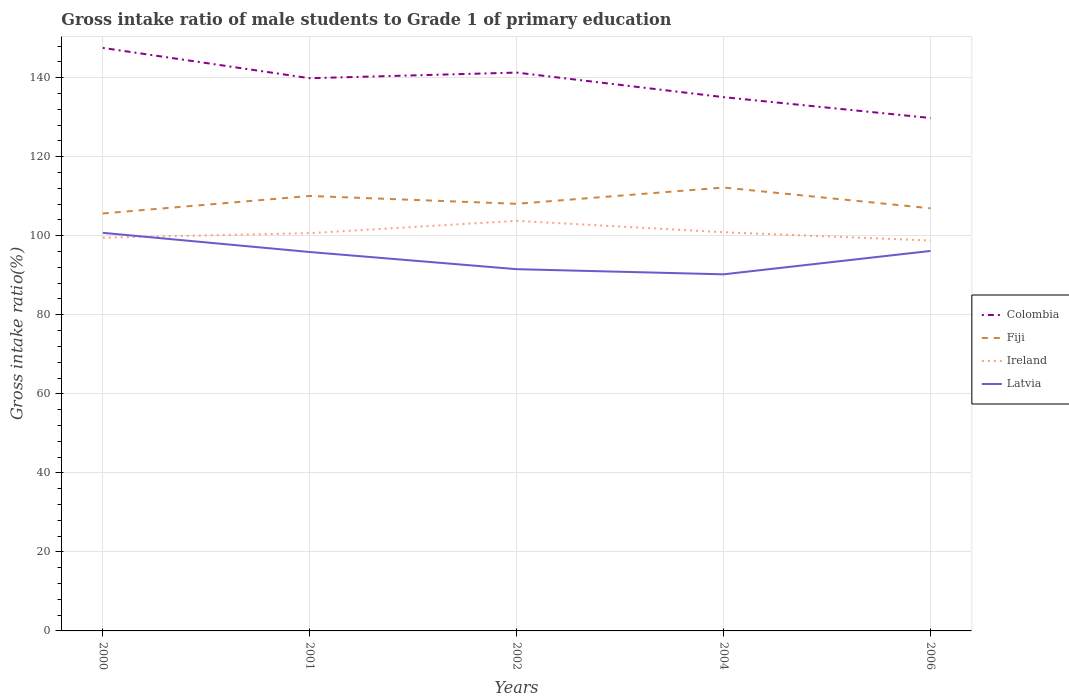Across all years, what is the maximum gross intake ratio in Latvia?
Provide a succinct answer. 90.24. What is the total gross intake ratio in Ireland in the graph?
Give a very brief answer. -0.23. What is the difference between the highest and the second highest gross intake ratio in Colombia?
Your answer should be very brief. 17.74. Is the gross intake ratio in Latvia strictly greater than the gross intake ratio in Fiji over the years?
Provide a short and direct response. Yes. What is the difference between two consecutive major ticks on the Y-axis?
Your response must be concise. 20. Are the values on the major ticks of Y-axis written in scientific E-notation?
Provide a short and direct response. No. Does the graph contain grids?
Provide a succinct answer. Yes. Where does the legend appear in the graph?
Give a very brief answer. Center right. What is the title of the graph?
Give a very brief answer. Gross intake ratio of male students to Grade 1 of primary education. Does "Lebanon" appear as one of the legend labels in the graph?
Provide a succinct answer. No. What is the label or title of the X-axis?
Give a very brief answer. Years. What is the label or title of the Y-axis?
Provide a short and direct response. Gross intake ratio(%). What is the Gross intake ratio(%) in Colombia in 2000?
Your answer should be compact. 147.53. What is the Gross intake ratio(%) in Fiji in 2000?
Offer a very short reply. 105.64. What is the Gross intake ratio(%) in Ireland in 2000?
Ensure brevity in your answer.  99.51. What is the Gross intake ratio(%) of Latvia in 2000?
Give a very brief answer. 100.74. What is the Gross intake ratio(%) of Colombia in 2001?
Offer a very short reply. 139.86. What is the Gross intake ratio(%) of Fiji in 2001?
Give a very brief answer. 110.07. What is the Gross intake ratio(%) in Ireland in 2001?
Your response must be concise. 100.65. What is the Gross intake ratio(%) of Latvia in 2001?
Your response must be concise. 95.88. What is the Gross intake ratio(%) of Colombia in 2002?
Provide a short and direct response. 141.29. What is the Gross intake ratio(%) of Fiji in 2002?
Your answer should be compact. 108.08. What is the Gross intake ratio(%) of Ireland in 2002?
Make the answer very short. 103.77. What is the Gross intake ratio(%) of Latvia in 2002?
Provide a succinct answer. 91.54. What is the Gross intake ratio(%) of Colombia in 2004?
Give a very brief answer. 135.07. What is the Gross intake ratio(%) of Fiji in 2004?
Offer a terse response. 112.2. What is the Gross intake ratio(%) in Ireland in 2004?
Provide a succinct answer. 100.88. What is the Gross intake ratio(%) in Latvia in 2004?
Your response must be concise. 90.24. What is the Gross intake ratio(%) in Colombia in 2006?
Keep it short and to the point. 129.8. What is the Gross intake ratio(%) in Fiji in 2006?
Offer a very short reply. 106.95. What is the Gross intake ratio(%) of Ireland in 2006?
Provide a short and direct response. 98.79. What is the Gross intake ratio(%) in Latvia in 2006?
Your answer should be very brief. 96.15. Across all years, what is the maximum Gross intake ratio(%) of Colombia?
Ensure brevity in your answer.  147.53. Across all years, what is the maximum Gross intake ratio(%) of Fiji?
Provide a succinct answer. 112.2. Across all years, what is the maximum Gross intake ratio(%) of Ireland?
Ensure brevity in your answer.  103.77. Across all years, what is the maximum Gross intake ratio(%) of Latvia?
Ensure brevity in your answer.  100.74. Across all years, what is the minimum Gross intake ratio(%) of Colombia?
Make the answer very short. 129.8. Across all years, what is the minimum Gross intake ratio(%) in Fiji?
Provide a short and direct response. 105.64. Across all years, what is the minimum Gross intake ratio(%) in Ireland?
Offer a very short reply. 98.79. Across all years, what is the minimum Gross intake ratio(%) of Latvia?
Ensure brevity in your answer.  90.24. What is the total Gross intake ratio(%) of Colombia in the graph?
Ensure brevity in your answer.  693.55. What is the total Gross intake ratio(%) in Fiji in the graph?
Your response must be concise. 542.93. What is the total Gross intake ratio(%) in Ireland in the graph?
Offer a very short reply. 503.62. What is the total Gross intake ratio(%) of Latvia in the graph?
Offer a terse response. 474.54. What is the difference between the Gross intake ratio(%) in Colombia in 2000 and that in 2001?
Offer a very short reply. 7.67. What is the difference between the Gross intake ratio(%) in Fiji in 2000 and that in 2001?
Offer a very short reply. -4.43. What is the difference between the Gross intake ratio(%) of Ireland in 2000 and that in 2001?
Give a very brief answer. -1.14. What is the difference between the Gross intake ratio(%) in Latvia in 2000 and that in 2001?
Your response must be concise. 4.85. What is the difference between the Gross intake ratio(%) of Colombia in 2000 and that in 2002?
Offer a terse response. 6.25. What is the difference between the Gross intake ratio(%) of Fiji in 2000 and that in 2002?
Provide a succinct answer. -2.45. What is the difference between the Gross intake ratio(%) in Ireland in 2000 and that in 2002?
Your answer should be compact. -4.26. What is the difference between the Gross intake ratio(%) in Latvia in 2000 and that in 2002?
Provide a succinct answer. 9.2. What is the difference between the Gross intake ratio(%) in Colombia in 2000 and that in 2004?
Keep it short and to the point. 12.46. What is the difference between the Gross intake ratio(%) of Fiji in 2000 and that in 2004?
Give a very brief answer. -6.57. What is the difference between the Gross intake ratio(%) in Ireland in 2000 and that in 2004?
Ensure brevity in your answer.  -1.37. What is the difference between the Gross intake ratio(%) of Latvia in 2000 and that in 2004?
Offer a terse response. 10.5. What is the difference between the Gross intake ratio(%) in Colombia in 2000 and that in 2006?
Ensure brevity in your answer.  17.74. What is the difference between the Gross intake ratio(%) in Fiji in 2000 and that in 2006?
Keep it short and to the point. -1.31. What is the difference between the Gross intake ratio(%) of Ireland in 2000 and that in 2006?
Offer a very short reply. 0.72. What is the difference between the Gross intake ratio(%) of Latvia in 2000 and that in 2006?
Provide a short and direct response. 4.59. What is the difference between the Gross intake ratio(%) of Colombia in 2001 and that in 2002?
Your answer should be compact. -1.42. What is the difference between the Gross intake ratio(%) in Fiji in 2001 and that in 2002?
Keep it short and to the point. 1.99. What is the difference between the Gross intake ratio(%) in Ireland in 2001 and that in 2002?
Make the answer very short. -3.12. What is the difference between the Gross intake ratio(%) in Latvia in 2001 and that in 2002?
Provide a short and direct response. 4.34. What is the difference between the Gross intake ratio(%) in Colombia in 2001 and that in 2004?
Ensure brevity in your answer.  4.79. What is the difference between the Gross intake ratio(%) in Fiji in 2001 and that in 2004?
Provide a succinct answer. -2.13. What is the difference between the Gross intake ratio(%) in Ireland in 2001 and that in 2004?
Ensure brevity in your answer.  -0.23. What is the difference between the Gross intake ratio(%) of Latvia in 2001 and that in 2004?
Offer a very short reply. 5.65. What is the difference between the Gross intake ratio(%) of Colombia in 2001 and that in 2006?
Offer a very short reply. 10.07. What is the difference between the Gross intake ratio(%) in Fiji in 2001 and that in 2006?
Ensure brevity in your answer.  3.12. What is the difference between the Gross intake ratio(%) of Ireland in 2001 and that in 2006?
Your response must be concise. 1.86. What is the difference between the Gross intake ratio(%) of Latvia in 2001 and that in 2006?
Ensure brevity in your answer.  -0.27. What is the difference between the Gross intake ratio(%) of Colombia in 2002 and that in 2004?
Your answer should be very brief. 6.22. What is the difference between the Gross intake ratio(%) of Fiji in 2002 and that in 2004?
Give a very brief answer. -4.12. What is the difference between the Gross intake ratio(%) in Ireland in 2002 and that in 2004?
Provide a succinct answer. 2.89. What is the difference between the Gross intake ratio(%) in Latvia in 2002 and that in 2004?
Provide a short and direct response. 1.3. What is the difference between the Gross intake ratio(%) of Colombia in 2002 and that in 2006?
Keep it short and to the point. 11.49. What is the difference between the Gross intake ratio(%) of Fiji in 2002 and that in 2006?
Your answer should be very brief. 1.13. What is the difference between the Gross intake ratio(%) in Ireland in 2002 and that in 2006?
Offer a very short reply. 4.98. What is the difference between the Gross intake ratio(%) of Latvia in 2002 and that in 2006?
Provide a short and direct response. -4.61. What is the difference between the Gross intake ratio(%) in Colombia in 2004 and that in 2006?
Offer a terse response. 5.27. What is the difference between the Gross intake ratio(%) in Fiji in 2004 and that in 2006?
Provide a succinct answer. 5.26. What is the difference between the Gross intake ratio(%) in Ireland in 2004 and that in 2006?
Offer a terse response. 2.09. What is the difference between the Gross intake ratio(%) of Latvia in 2004 and that in 2006?
Make the answer very short. -5.91. What is the difference between the Gross intake ratio(%) of Colombia in 2000 and the Gross intake ratio(%) of Fiji in 2001?
Provide a short and direct response. 37.46. What is the difference between the Gross intake ratio(%) of Colombia in 2000 and the Gross intake ratio(%) of Ireland in 2001?
Make the answer very short. 46.88. What is the difference between the Gross intake ratio(%) of Colombia in 2000 and the Gross intake ratio(%) of Latvia in 2001?
Your answer should be very brief. 51.65. What is the difference between the Gross intake ratio(%) in Fiji in 2000 and the Gross intake ratio(%) in Ireland in 2001?
Offer a terse response. 4.98. What is the difference between the Gross intake ratio(%) in Fiji in 2000 and the Gross intake ratio(%) in Latvia in 2001?
Your response must be concise. 9.75. What is the difference between the Gross intake ratio(%) of Ireland in 2000 and the Gross intake ratio(%) of Latvia in 2001?
Provide a short and direct response. 3.63. What is the difference between the Gross intake ratio(%) in Colombia in 2000 and the Gross intake ratio(%) in Fiji in 2002?
Your answer should be compact. 39.45. What is the difference between the Gross intake ratio(%) in Colombia in 2000 and the Gross intake ratio(%) in Ireland in 2002?
Make the answer very short. 43.76. What is the difference between the Gross intake ratio(%) of Colombia in 2000 and the Gross intake ratio(%) of Latvia in 2002?
Offer a very short reply. 55.99. What is the difference between the Gross intake ratio(%) in Fiji in 2000 and the Gross intake ratio(%) in Ireland in 2002?
Make the answer very short. 1.86. What is the difference between the Gross intake ratio(%) of Fiji in 2000 and the Gross intake ratio(%) of Latvia in 2002?
Keep it short and to the point. 14.1. What is the difference between the Gross intake ratio(%) of Ireland in 2000 and the Gross intake ratio(%) of Latvia in 2002?
Keep it short and to the point. 7.97. What is the difference between the Gross intake ratio(%) in Colombia in 2000 and the Gross intake ratio(%) in Fiji in 2004?
Keep it short and to the point. 35.33. What is the difference between the Gross intake ratio(%) of Colombia in 2000 and the Gross intake ratio(%) of Ireland in 2004?
Offer a terse response. 46.65. What is the difference between the Gross intake ratio(%) in Colombia in 2000 and the Gross intake ratio(%) in Latvia in 2004?
Provide a succinct answer. 57.3. What is the difference between the Gross intake ratio(%) of Fiji in 2000 and the Gross intake ratio(%) of Ireland in 2004?
Provide a short and direct response. 4.75. What is the difference between the Gross intake ratio(%) in Fiji in 2000 and the Gross intake ratio(%) in Latvia in 2004?
Your answer should be compact. 15.4. What is the difference between the Gross intake ratio(%) in Ireland in 2000 and the Gross intake ratio(%) in Latvia in 2004?
Make the answer very short. 9.28. What is the difference between the Gross intake ratio(%) of Colombia in 2000 and the Gross intake ratio(%) of Fiji in 2006?
Give a very brief answer. 40.59. What is the difference between the Gross intake ratio(%) in Colombia in 2000 and the Gross intake ratio(%) in Ireland in 2006?
Provide a short and direct response. 48.74. What is the difference between the Gross intake ratio(%) of Colombia in 2000 and the Gross intake ratio(%) of Latvia in 2006?
Offer a terse response. 51.38. What is the difference between the Gross intake ratio(%) of Fiji in 2000 and the Gross intake ratio(%) of Ireland in 2006?
Provide a succinct answer. 6.84. What is the difference between the Gross intake ratio(%) in Fiji in 2000 and the Gross intake ratio(%) in Latvia in 2006?
Keep it short and to the point. 9.49. What is the difference between the Gross intake ratio(%) of Ireland in 2000 and the Gross intake ratio(%) of Latvia in 2006?
Keep it short and to the point. 3.36. What is the difference between the Gross intake ratio(%) in Colombia in 2001 and the Gross intake ratio(%) in Fiji in 2002?
Keep it short and to the point. 31.78. What is the difference between the Gross intake ratio(%) in Colombia in 2001 and the Gross intake ratio(%) in Ireland in 2002?
Offer a very short reply. 36.09. What is the difference between the Gross intake ratio(%) in Colombia in 2001 and the Gross intake ratio(%) in Latvia in 2002?
Your response must be concise. 48.32. What is the difference between the Gross intake ratio(%) in Fiji in 2001 and the Gross intake ratio(%) in Ireland in 2002?
Offer a very short reply. 6.29. What is the difference between the Gross intake ratio(%) of Fiji in 2001 and the Gross intake ratio(%) of Latvia in 2002?
Keep it short and to the point. 18.53. What is the difference between the Gross intake ratio(%) of Ireland in 2001 and the Gross intake ratio(%) of Latvia in 2002?
Your response must be concise. 9.11. What is the difference between the Gross intake ratio(%) in Colombia in 2001 and the Gross intake ratio(%) in Fiji in 2004?
Make the answer very short. 27.66. What is the difference between the Gross intake ratio(%) of Colombia in 2001 and the Gross intake ratio(%) of Ireland in 2004?
Give a very brief answer. 38.98. What is the difference between the Gross intake ratio(%) in Colombia in 2001 and the Gross intake ratio(%) in Latvia in 2004?
Offer a very short reply. 49.63. What is the difference between the Gross intake ratio(%) of Fiji in 2001 and the Gross intake ratio(%) of Ireland in 2004?
Your answer should be compact. 9.18. What is the difference between the Gross intake ratio(%) of Fiji in 2001 and the Gross intake ratio(%) of Latvia in 2004?
Your answer should be compact. 19.83. What is the difference between the Gross intake ratio(%) in Ireland in 2001 and the Gross intake ratio(%) in Latvia in 2004?
Provide a succinct answer. 10.41. What is the difference between the Gross intake ratio(%) of Colombia in 2001 and the Gross intake ratio(%) of Fiji in 2006?
Offer a terse response. 32.92. What is the difference between the Gross intake ratio(%) of Colombia in 2001 and the Gross intake ratio(%) of Ireland in 2006?
Ensure brevity in your answer.  41.07. What is the difference between the Gross intake ratio(%) of Colombia in 2001 and the Gross intake ratio(%) of Latvia in 2006?
Your answer should be compact. 43.71. What is the difference between the Gross intake ratio(%) of Fiji in 2001 and the Gross intake ratio(%) of Ireland in 2006?
Offer a terse response. 11.28. What is the difference between the Gross intake ratio(%) of Fiji in 2001 and the Gross intake ratio(%) of Latvia in 2006?
Offer a very short reply. 13.92. What is the difference between the Gross intake ratio(%) of Ireland in 2001 and the Gross intake ratio(%) of Latvia in 2006?
Your answer should be very brief. 4.5. What is the difference between the Gross intake ratio(%) of Colombia in 2002 and the Gross intake ratio(%) of Fiji in 2004?
Keep it short and to the point. 29.08. What is the difference between the Gross intake ratio(%) of Colombia in 2002 and the Gross intake ratio(%) of Ireland in 2004?
Ensure brevity in your answer.  40.4. What is the difference between the Gross intake ratio(%) in Colombia in 2002 and the Gross intake ratio(%) in Latvia in 2004?
Your answer should be compact. 51.05. What is the difference between the Gross intake ratio(%) of Fiji in 2002 and the Gross intake ratio(%) of Ireland in 2004?
Your response must be concise. 7.2. What is the difference between the Gross intake ratio(%) in Fiji in 2002 and the Gross intake ratio(%) in Latvia in 2004?
Give a very brief answer. 17.84. What is the difference between the Gross intake ratio(%) in Ireland in 2002 and the Gross intake ratio(%) in Latvia in 2004?
Provide a succinct answer. 13.54. What is the difference between the Gross intake ratio(%) in Colombia in 2002 and the Gross intake ratio(%) in Fiji in 2006?
Ensure brevity in your answer.  34.34. What is the difference between the Gross intake ratio(%) of Colombia in 2002 and the Gross intake ratio(%) of Ireland in 2006?
Offer a terse response. 42.5. What is the difference between the Gross intake ratio(%) in Colombia in 2002 and the Gross intake ratio(%) in Latvia in 2006?
Ensure brevity in your answer.  45.14. What is the difference between the Gross intake ratio(%) of Fiji in 2002 and the Gross intake ratio(%) of Ireland in 2006?
Your answer should be compact. 9.29. What is the difference between the Gross intake ratio(%) in Fiji in 2002 and the Gross intake ratio(%) in Latvia in 2006?
Your response must be concise. 11.93. What is the difference between the Gross intake ratio(%) in Ireland in 2002 and the Gross intake ratio(%) in Latvia in 2006?
Your answer should be very brief. 7.62. What is the difference between the Gross intake ratio(%) of Colombia in 2004 and the Gross intake ratio(%) of Fiji in 2006?
Ensure brevity in your answer.  28.12. What is the difference between the Gross intake ratio(%) of Colombia in 2004 and the Gross intake ratio(%) of Ireland in 2006?
Your answer should be compact. 36.28. What is the difference between the Gross intake ratio(%) of Colombia in 2004 and the Gross intake ratio(%) of Latvia in 2006?
Keep it short and to the point. 38.92. What is the difference between the Gross intake ratio(%) in Fiji in 2004 and the Gross intake ratio(%) in Ireland in 2006?
Offer a terse response. 13.41. What is the difference between the Gross intake ratio(%) of Fiji in 2004 and the Gross intake ratio(%) of Latvia in 2006?
Keep it short and to the point. 16.05. What is the difference between the Gross intake ratio(%) in Ireland in 2004 and the Gross intake ratio(%) in Latvia in 2006?
Give a very brief answer. 4.73. What is the average Gross intake ratio(%) in Colombia per year?
Make the answer very short. 138.71. What is the average Gross intake ratio(%) in Fiji per year?
Ensure brevity in your answer.  108.59. What is the average Gross intake ratio(%) in Ireland per year?
Keep it short and to the point. 100.72. What is the average Gross intake ratio(%) in Latvia per year?
Provide a short and direct response. 94.91. In the year 2000, what is the difference between the Gross intake ratio(%) of Colombia and Gross intake ratio(%) of Fiji?
Provide a succinct answer. 41.9. In the year 2000, what is the difference between the Gross intake ratio(%) of Colombia and Gross intake ratio(%) of Ireland?
Keep it short and to the point. 48.02. In the year 2000, what is the difference between the Gross intake ratio(%) of Colombia and Gross intake ratio(%) of Latvia?
Offer a very short reply. 46.8. In the year 2000, what is the difference between the Gross intake ratio(%) in Fiji and Gross intake ratio(%) in Ireland?
Your answer should be very brief. 6.12. In the year 2000, what is the difference between the Gross intake ratio(%) of Fiji and Gross intake ratio(%) of Latvia?
Your answer should be very brief. 4.9. In the year 2000, what is the difference between the Gross intake ratio(%) of Ireland and Gross intake ratio(%) of Latvia?
Provide a short and direct response. -1.22. In the year 2001, what is the difference between the Gross intake ratio(%) of Colombia and Gross intake ratio(%) of Fiji?
Make the answer very short. 29.8. In the year 2001, what is the difference between the Gross intake ratio(%) in Colombia and Gross intake ratio(%) in Ireland?
Offer a terse response. 39.21. In the year 2001, what is the difference between the Gross intake ratio(%) in Colombia and Gross intake ratio(%) in Latvia?
Your answer should be compact. 43.98. In the year 2001, what is the difference between the Gross intake ratio(%) of Fiji and Gross intake ratio(%) of Ireland?
Keep it short and to the point. 9.42. In the year 2001, what is the difference between the Gross intake ratio(%) in Fiji and Gross intake ratio(%) in Latvia?
Ensure brevity in your answer.  14.19. In the year 2001, what is the difference between the Gross intake ratio(%) in Ireland and Gross intake ratio(%) in Latvia?
Provide a succinct answer. 4.77. In the year 2002, what is the difference between the Gross intake ratio(%) in Colombia and Gross intake ratio(%) in Fiji?
Your response must be concise. 33.21. In the year 2002, what is the difference between the Gross intake ratio(%) of Colombia and Gross intake ratio(%) of Ireland?
Ensure brevity in your answer.  37.51. In the year 2002, what is the difference between the Gross intake ratio(%) in Colombia and Gross intake ratio(%) in Latvia?
Provide a short and direct response. 49.75. In the year 2002, what is the difference between the Gross intake ratio(%) in Fiji and Gross intake ratio(%) in Ireland?
Your answer should be very brief. 4.31. In the year 2002, what is the difference between the Gross intake ratio(%) in Fiji and Gross intake ratio(%) in Latvia?
Ensure brevity in your answer.  16.54. In the year 2002, what is the difference between the Gross intake ratio(%) of Ireland and Gross intake ratio(%) of Latvia?
Provide a succinct answer. 12.23. In the year 2004, what is the difference between the Gross intake ratio(%) in Colombia and Gross intake ratio(%) in Fiji?
Provide a short and direct response. 22.87. In the year 2004, what is the difference between the Gross intake ratio(%) of Colombia and Gross intake ratio(%) of Ireland?
Keep it short and to the point. 34.18. In the year 2004, what is the difference between the Gross intake ratio(%) of Colombia and Gross intake ratio(%) of Latvia?
Offer a terse response. 44.83. In the year 2004, what is the difference between the Gross intake ratio(%) in Fiji and Gross intake ratio(%) in Ireland?
Keep it short and to the point. 11.32. In the year 2004, what is the difference between the Gross intake ratio(%) of Fiji and Gross intake ratio(%) of Latvia?
Your answer should be compact. 21.97. In the year 2004, what is the difference between the Gross intake ratio(%) in Ireland and Gross intake ratio(%) in Latvia?
Ensure brevity in your answer.  10.65. In the year 2006, what is the difference between the Gross intake ratio(%) in Colombia and Gross intake ratio(%) in Fiji?
Keep it short and to the point. 22.85. In the year 2006, what is the difference between the Gross intake ratio(%) of Colombia and Gross intake ratio(%) of Ireland?
Offer a very short reply. 31. In the year 2006, what is the difference between the Gross intake ratio(%) of Colombia and Gross intake ratio(%) of Latvia?
Make the answer very short. 33.65. In the year 2006, what is the difference between the Gross intake ratio(%) of Fiji and Gross intake ratio(%) of Ireland?
Make the answer very short. 8.15. In the year 2006, what is the difference between the Gross intake ratio(%) of Fiji and Gross intake ratio(%) of Latvia?
Offer a very short reply. 10.8. In the year 2006, what is the difference between the Gross intake ratio(%) in Ireland and Gross intake ratio(%) in Latvia?
Offer a very short reply. 2.64. What is the ratio of the Gross intake ratio(%) in Colombia in 2000 to that in 2001?
Provide a succinct answer. 1.05. What is the ratio of the Gross intake ratio(%) of Fiji in 2000 to that in 2001?
Your response must be concise. 0.96. What is the ratio of the Gross intake ratio(%) of Ireland in 2000 to that in 2001?
Offer a very short reply. 0.99. What is the ratio of the Gross intake ratio(%) of Latvia in 2000 to that in 2001?
Ensure brevity in your answer.  1.05. What is the ratio of the Gross intake ratio(%) of Colombia in 2000 to that in 2002?
Give a very brief answer. 1.04. What is the ratio of the Gross intake ratio(%) of Fiji in 2000 to that in 2002?
Ensure brevity in your answer.  0.98. What is the ratio of the Gross intake ratio(%) of Ireland in 2000 to that in 2002?
Your answer should be compact. 0.96. What is the ratio of the Gross intake ratio(%) in Latvia in 2000 to that in 2002?
Your answer should be compact. 1.1. What is the ratio of the Gross intake ratio(%) in Colombia in 2000 to that in 2004?
Your answer should be very brief. 1.09. What is the ratio of the Gross intake ratio(%) of Fiji in 2000 to that in 2004?
Offer a terse response. 0.94. What is the ratio of the Gross intake ratio(%) in Ireland in 2000 to that in 2004?
Offer a terse response. 0.99. What is the ratio of the Gross intake ratio(%) of Latvia in 2000 to that in 2004?
Make the answer very short. 1.12. What is the ratio of the Gross intake ratio(%) of Colombia in 2000 to that in 2006?
Ensure brevity in your answer.  1.14. What is the ratio of the Gross intake ratio(%) in Fiji in 2000 to that in 2006?
Your response must be concise. 0.99. What is the ratio of the Gross intake ratio(%) of Ireland in 2000 to that in 2006?
Ensure brevity in your answer.  1.01. What is the ratio of the Gross intake ratio(%) of Latvia in 2000 to that in 2006?
Provide a succinct answer. 1.05. What is the ratio of the Gross intake ratio(%) in Fiji in 2001 to that in 2002?
Ensure brevity in your answer.  1.02. What is the ratio of the Gross intake ratio(%) of Ireland in 2001 to that in 2002?
Offer a terse response. 0.97. What is the ratio of the Gross intake ratio(%) in Latvia in 2001 to that in 2002?
Keep it short and to the point. 1.05. What is the ratio of the Gross intake ratio(%) of Colombia in 2001 to that in 2004?
Your answer should be compact. 1.04. What is the ratio of the Gross intake ratio(%) in Fiji in 2001 to that in 2004?
Make the answer very short. 0.98. What is the ratio of the Gross intake ratio(%) in Latvia in 2001 to that in 2004?
Provide a short and direct response. 1.06. What is the ratio of the Gross intake ratio(%) of Colombia in 2001 to that in 2006?
Offer a very short reply. 1.08. What is the ratio of the Gross intake ratio(%) of Fiji in 2001 to that in 2006?
Offer a very short reply. 1.03. What is the ratio of the Gross intake ratio(%) in Ireland in 2001 to that in 2006?
Offer a very short reply. 1.02. What is the ratio of the Gross intake ratio(%) in Latvia in 2001 to that in 2006?
Make the answer very short. 1. What is the ratio of the Gross intake ratio(%) of Colombia in 2002 to that in 2004?
Your answer should be compact. 1.05. What is the ratio of the Gross intake ratio(%) of Fiji in 2002 to that in 2004?
Your answer should be compact. 0.96. What is the ratio of the Gross intake ratio(%) of Ireland in 2002 to that in 2004?
Your answer should be compact. 1.03. What is the ratio of the Gross intake ratio(%) of Latvia in 2002 to that in 2004?
Give a very brief answer. 1.01. What is the ratio of the Gross intake ratio(%) of Colombia in 2002 to that in 2006?
Your answer should be very brief. 1.09. What is the ratio of the Gross intake ratio(%) of Fiji in 2002 to that in 2006?
Provide a succinct answer. 1.01. What is the ratio of the Gross intake ratio(%) in Ireland in 2002 to that in 2006?
Ensure brevity in your answer.  1.05. What is the ratio of the Gross intake ratio(%) of Latvia in 2002 to that in 2006?
Make the answer very short. 0.95. What is the ratio of the Gross intake ratio(%) in Colombia in 2004 to that in 2006?
Offer a very short reply. 1.04. What is the ratio of the Gross intake ratio(%) of Fiji in 2004 to that in 2006?
Give a very brief answer. 1.05. What is the ratio of the Gross intake ratio(%) in Ireland in 2004 to that in 2006?
Offer a very short reply. 1.02. What is the ratio of the Gross intake ratio(%) in Latvia in 2004 to that in 2006?
Your response must be concise. 0.94. What is the difference between the highest and the second highest Gross intake ratio(%) in Colombia?
Offer a terse response. 6.25. What is the difference between the highest and the second highest Gross intake ratio(%) of Fiji?
Your response must be concise. 2.13. What is the difference between the highest and the second highest Gross intake ratio(%) in Ireland?
Offer a terse response. 2.89. What is the difference between the highest and the second highest Gross intake ratio(%) of Latvia?
Ensure brevity in your answer.  4.59. What is the difference between the highest and the lowest Gross intake ratio(%) of Colombia?
Ensure brevity in your answer.  17.74. What is the difference between the highest and the lowest Gross intake ratio(%) of Fiji?
Ensure brevity in your answer.  6.57. What is the difference between the highest and the lowest Gross intake ratio(%) in Ireland?
Make the answer very short. 4.98. What is the difference between the highest and the lowest Gross intake ratio(%) in Latvia?
Your answer should be compact. 10.5. 